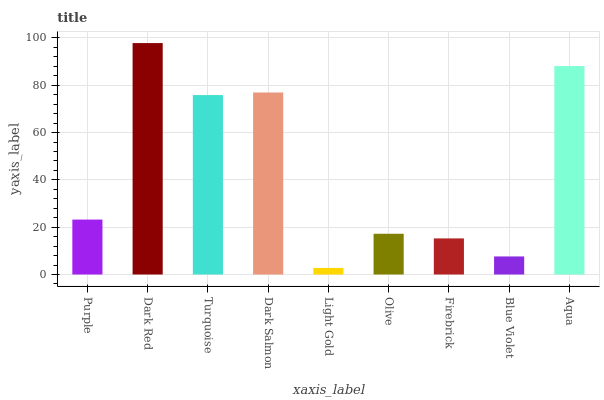Is Turquoise the minimum?
Answer yes or no. No. Is Turquoise the maximum?
Answer yes or no. No. Is Dark Red greater than Turquoise?
Answer yes or no. Yes. Is Turquoise less than Dark Red?
Answer yes or no. Yes. Is Turquoise greater than Dark Red?
Answer yes or no. No. Is Dark Red less than Turquoise?
Answer yes or no. No. Is Purple the high median?
Answer yes or no. Yes. Is Purple the low median?
Answer yes or no. Yes. Is Dark Red the high median?
Answer yes or no. No. Is Olive the low median?
Answer yes or no. No. 